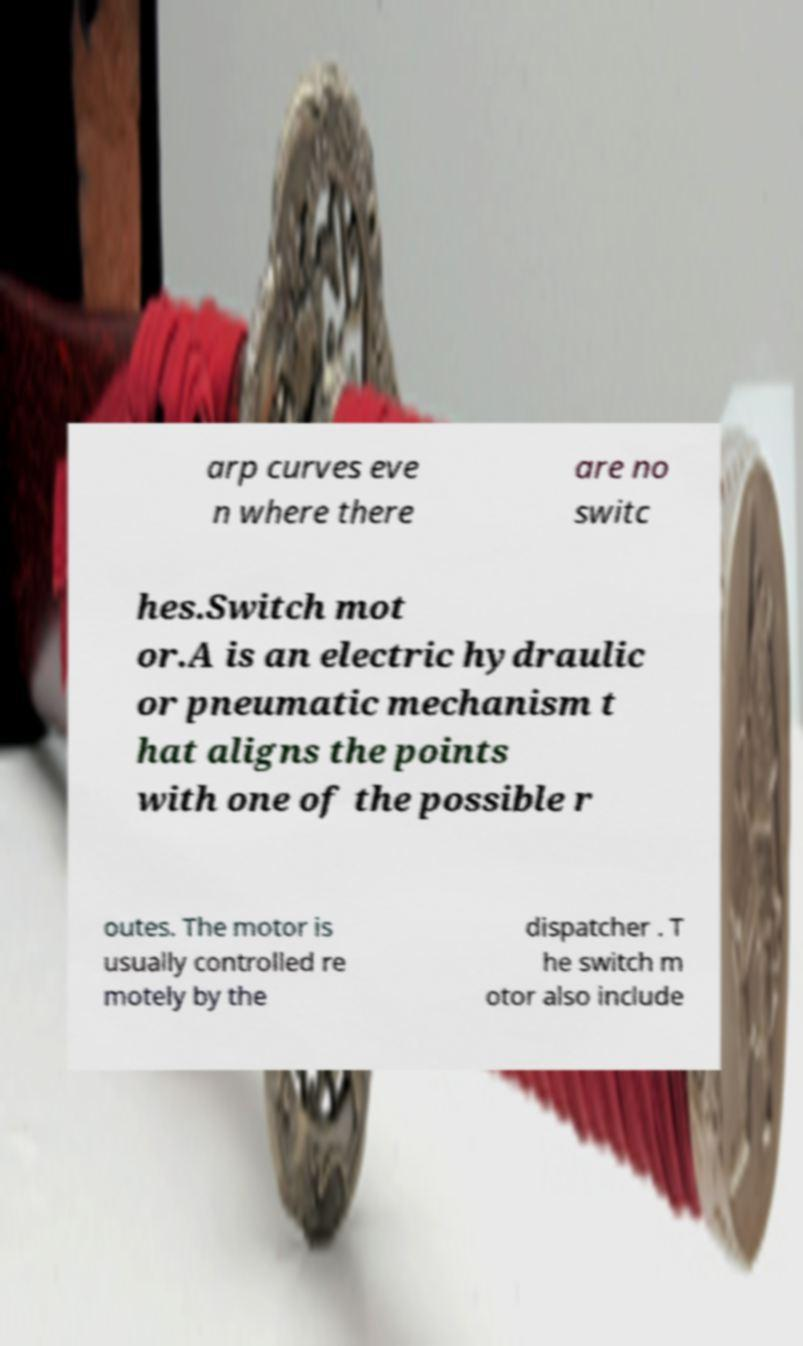For documentation purposes, I need the text within this image transcribed. Could you provide that? arp curves eve n where there are no switc hes.Switch mot or.A is an electric hydraulic or pneumatic mechanism t hat aligns the points with one of the possible r outes. The motor is usually controlled re motely by the dispatcher . T he switch m otor also include 